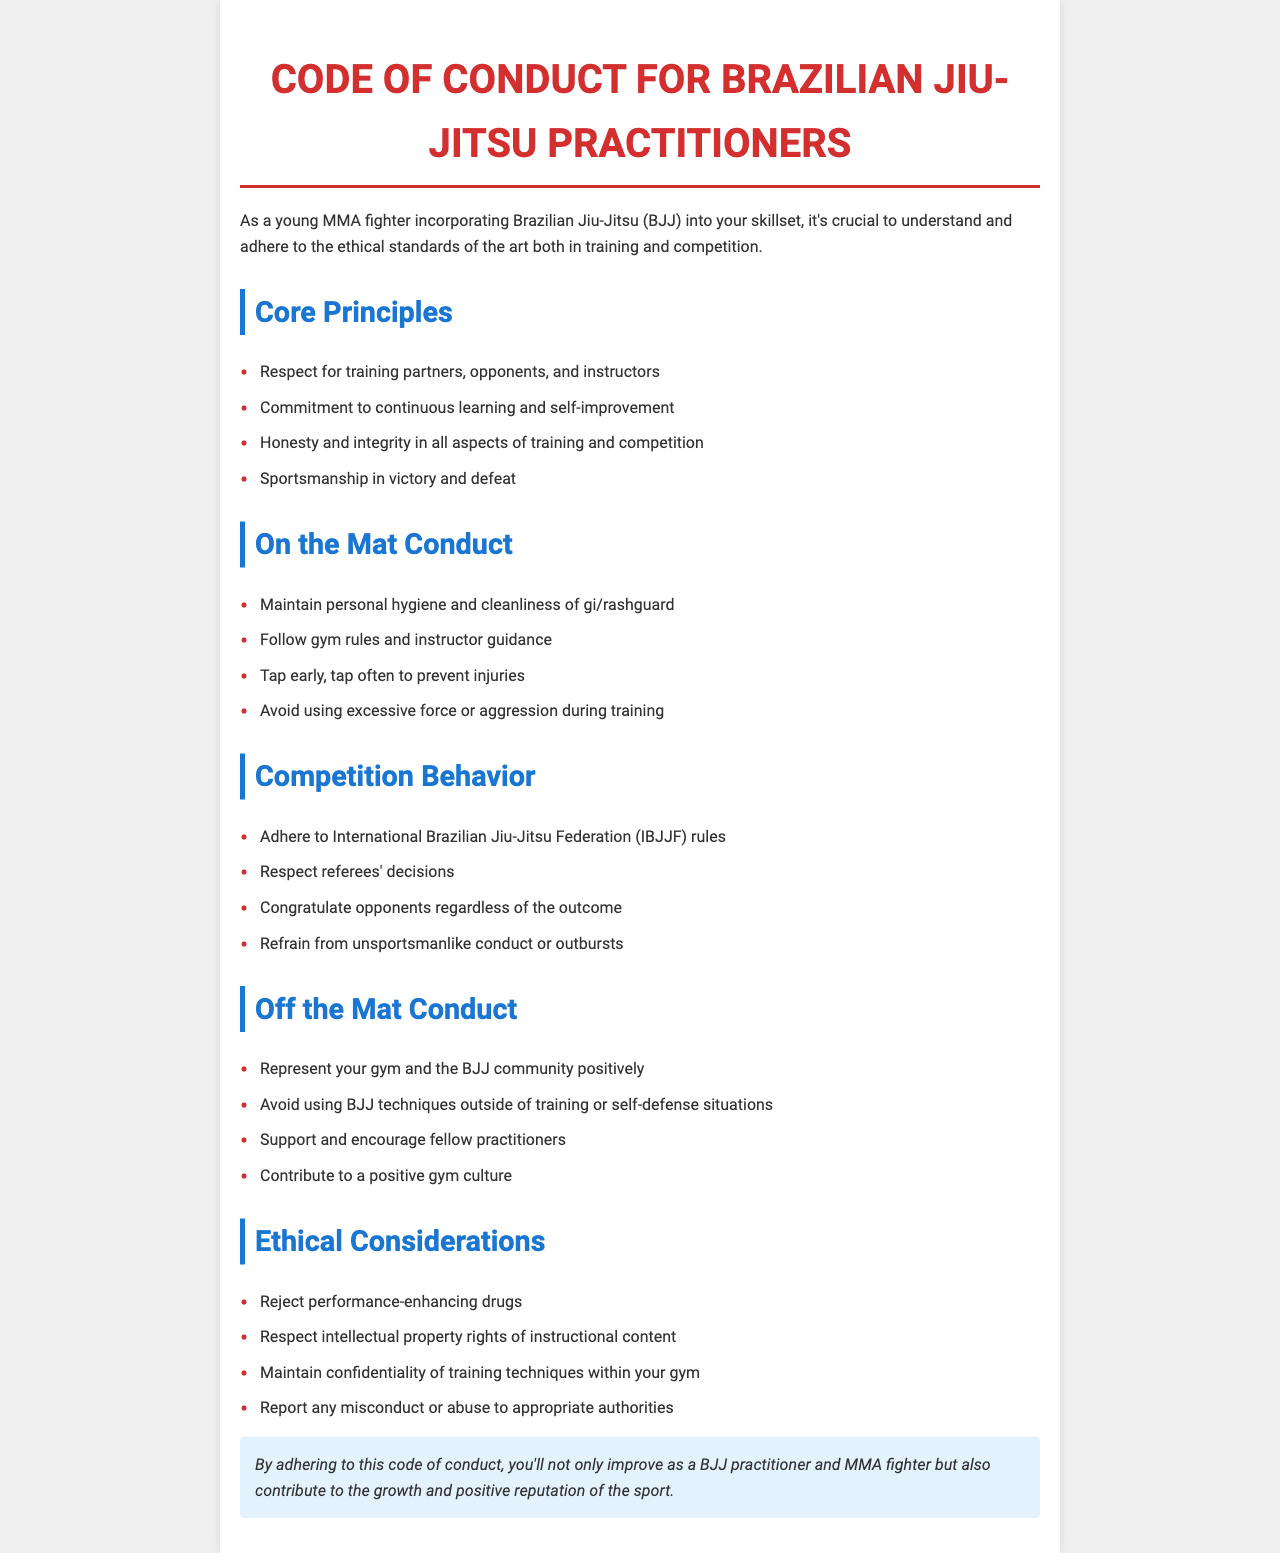What are the core principles of the Code of Conduct? The core principles are listed in the document and include respect, commitment, integrity, and sportsmanship.
Answer: Respect for training partners, opponents, and instructors, commitment to continuous learning and self-improvement, honesty and integrity in all aspects of training and competition, sportsmanship in victory and defeat What should you do to avoid injuries during training? The document suggests a specific behavior regarding injury prevention during training.
Answer: Tap early, tap often to prevent injuries What do you need to maintain for on-mat conduct? The document specifies a key aspect of personal maintenance required for on-mat conduct.
Answer: Personal hygiene and cleanliness of gi/rashguard What is expected from competitors regarding referee decisions? The document outlines an important behavior regarding referees that competitors must adhere to during competitions.
Answer: Respect referees' decisions What should you avoid doing off the mat? This question pertains to the guidelines related to off-mat conduct described in the document.
Answer: Avoid using BJJ techniques outside of training or self-defense situations How should you behave after a competition? The document states a specific courtesy that competitors should extend towards their opponents.
Answer: Congratulate opponents regardless of the outcome What are participants expected to reject according to ethical considerations? The document emphasizes a critical ethical principle that participants should follow.
Answer: Performance-enhancing drugs What document does the Code of Conduct adhere to during competition? This question focuses on the regulatory framework mentioned in the document for competitive events.
Answer: International Brazilian Jiu-Jitsu Federation (IBJJF) rules 